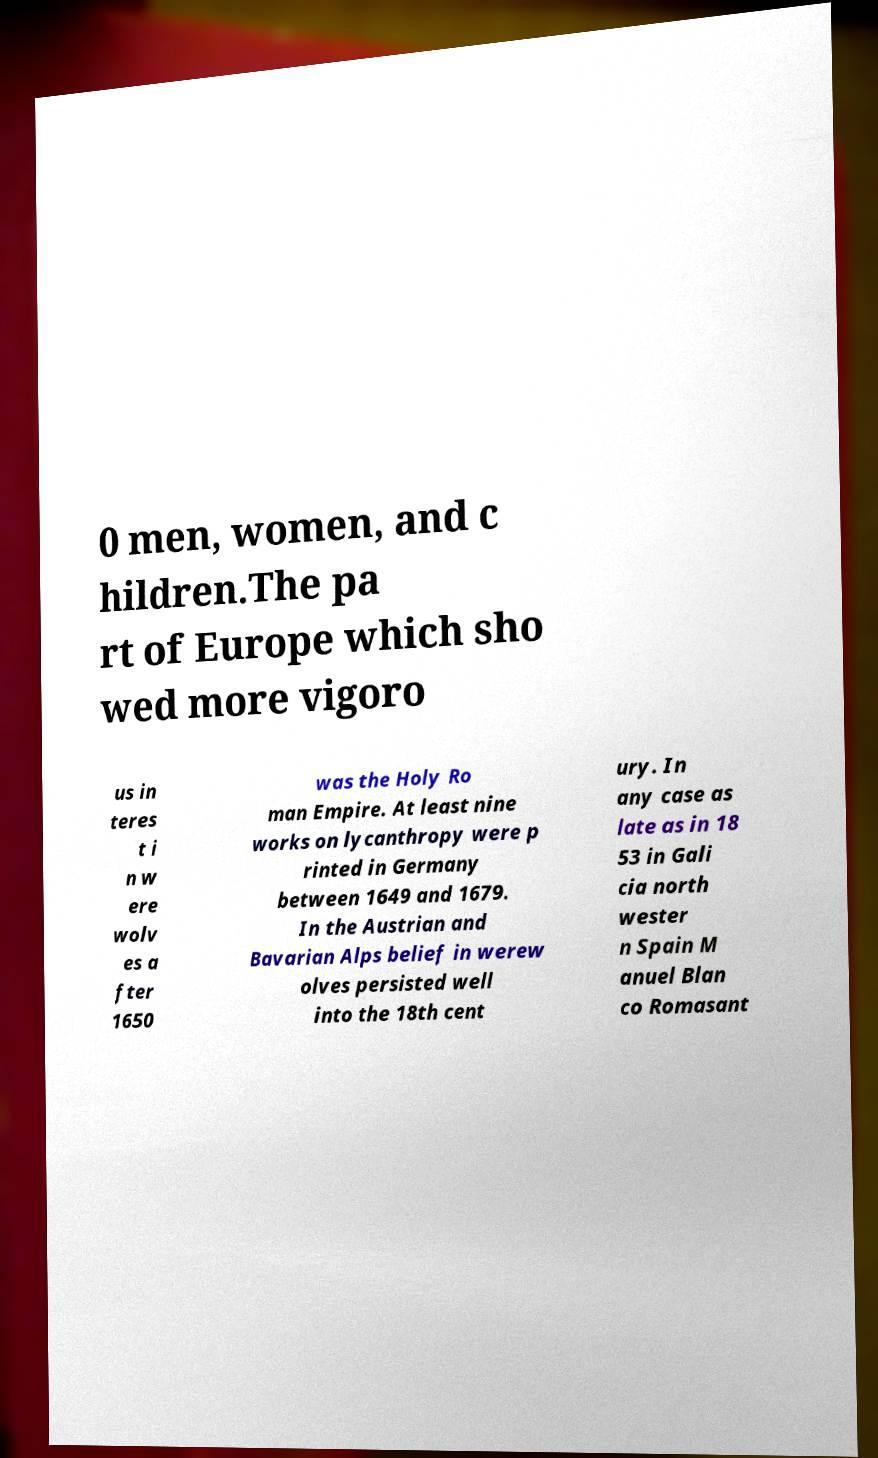I need the written content from this picture converted into text. Can you do that? 0 men, women, and c hildren.The pa rt of Europe which sho wed more vigoro us in teres t i n w ere wolv es a fter 1650 was the Holy Ro man Empire. At least nine works on lycanthropy were p rinted in Germany between 1649 and 1679. In the Austrian and Bavarian Alps belief in werew olves persisted well into the 18th cent ury. In any case as late as in 18 53 in Gali cia north wester n Spain M anuel Blan co Romasant 